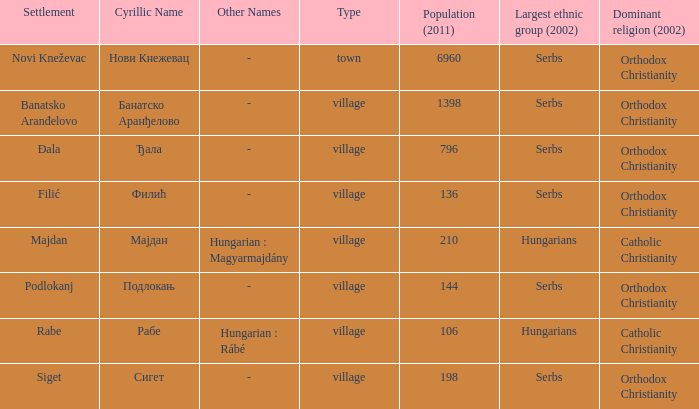In the settlement with the cyrillic designation банатско аранђелово, which ethnic group is the most populous? Serbs. 